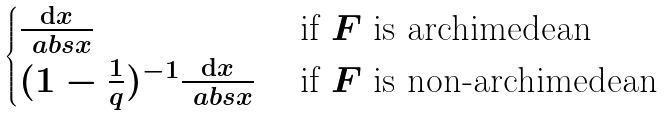<formula> <loc_0><loc_0><loc_500><loc_500>\begin{cases} \frac { \mathrm d x } { \ a b s { x } } & \text { if $F$ is archimedean} \\ ( 1 - \frac { 1 } { q } ) ^ { - 1 } \frac { \mathrm d x } { \ a b s { x } } & \text { if $F$ is non-archimedean} \end{cases}</formula> 